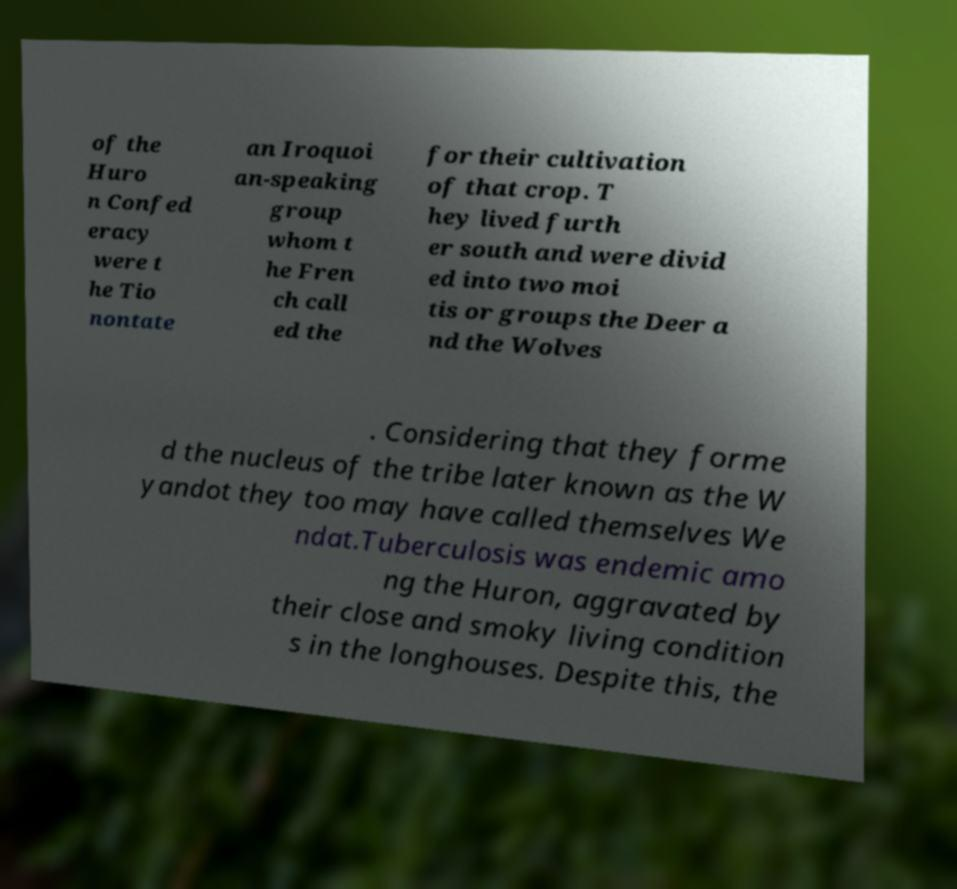Could you extract and type out the text from this image? of the Huro n Confed eracy were t he Tio nontate an Iroquoi an-speaking group whom t he Fren ch call ed the for their cultivation of that crop. T hey lived furth er south and were divid ed into two moi tis or groups the Deer a nd the Wolves . Considering that they forme d the nucleus of the tribe later known as the W yandot they too may have called themselves We ndat.Tuberculosis was endemic amo ng the Huron, aggravated by their close and smoky living condition s in the longhouses. Despite this, the 